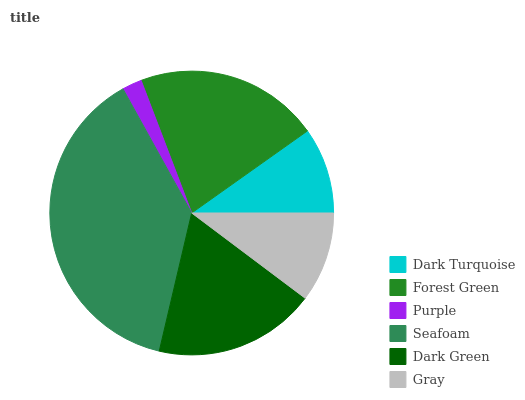Is Purple the minimum?
Answer yes or no. Yes. Is Seafoam the maximum?
Answer yes or no. Yes. Is Forest Green the minimum?
Answer yes or no. No. Is Forest Green the maximum?
Answer yes or no. No. Is Forest Green greater than Dark Turquoise?
Answer yes or no. Yes. Is Dark Turquoise less than Forest Green?
Answer yes or no. Yes. Is Dark Turquoise greater than Forest Green?
Answer yes or no. No. Is Forest Green less than Dark Turquoise?
Answer yes or no. No. Is Dark Green the high median?
Answer yes or no. Yes. Is Gray the low median?
Answer yes or no. Yes. Is Dark Turquoise the high median?
Answer yes or no. No. Is Purple the low median?
Answer yes or no. No. 